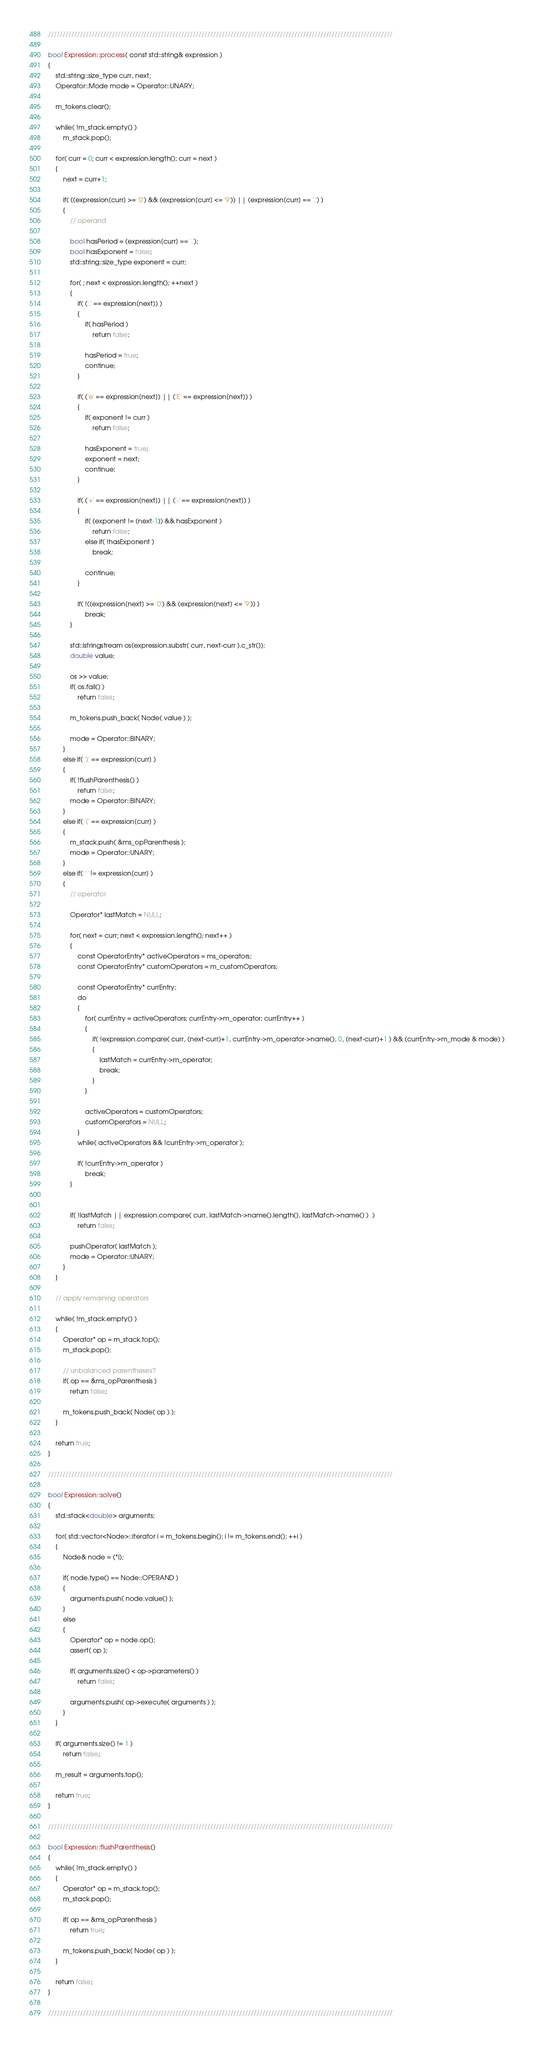Convert code to text. <code><loc_0><loc_0><loc_500><loc_500><_C++_>///////////////////////////////////////////////////////////////////////////////////////////////////////////////////////

bool Expression::process( const std::string& expression )
{
	std::string::size_type curr, next;
	Operator::Mode mode = Operator::UNARY;

	m_tokens.clear();

	while( !m_stack.empty() )
		m_stack.pop();

	for( curr = 0; curr < expression.length(); curr = next )
	{
		next = curr+1;

		if( ((expression[curr] >= '0') && (expression[curr] <= '9')) || (expression[curr] == '.') )
		{
			// operand

			bool hasPeriod = (expression[curr] == '.');
			bool hasExponent = false;
			std::string::size_type exponent = curr;

			for( ; next < expression.length(); ++next )
			{
				if( ('.' == expression[next]) )
				{
					if( hasPeriod )
						return false;

					hasPeriod = true;
					continue;
				}

				if( ('e' == expression[next]) || ('E' == expression[next]) )
				{
					if( exponent != curr )
						return false;

					hasExponent = true;
					exponent = next;
					continue;
				}

				if( ('+' == expression[next]) || ('-' == expression[next]) )
				{
					if( (exponent != (next-1)) && hasExponent )
						return false;
					else if( !hasExponent )
						break;

					continue;
				}
				
				if( !((expression[next] >= '0') && (expression[next] <= '9')) )
					break;
			}

			std::istringstream os(expression.substr( curr, next-curr ).c_str());
			double value;

			os >> value;
			if( os.fail() )
				return false;

			m_tokens.push_back( Node( value ) );

			mode = Operator::BINARY;
		}
		else if( ')' == expression[curr] )
		{
			if( !flushParenthesis() )
				return false;
			mode = Operator::BINARY;
		}
		else if( '(' == expression[curr] )
		{
			m_stack.push( &ms_opParenthesis );
			mode = Operator::UNARY;
		}
		else if( ' ' != expression[curr] )
		{
			// operator

			Operator* lastMatch = NULL;

			for( next = curr; next < expression.length(); next++ )
			{
				const OperatorEntry* activeOperators = ms_operators;
				const OperatorEntry* customOperators = m_customOperators;

				const OperatorEntry* currEntry;
				do
				{
					for( currEntry = activeOperators; currEntry->m_operator; currEntry++ )
					{
						if( !expression.compare( curr, (next-curr)+1, currEntry->m_operator->name(), 0, (next-curr)+1 ) && (currEntry->m_mode & mode) )
						{
							lastMatch = currEntry->m_operator;
							break;
						}
					}

					activeOperators = customOperators;
					customOperators = NULL;
				}
				while( activeOperators && !currEntry->m_operator );

				if( !currEntry->m_operator )
					break;
			}


			if( !lastMatch || expression.compare( curr, lastMatch->name().length(), lastMatch->name() )  )
				return false;

			pushOperator( lastMatch );
			mode = Operator::UNARY;
		}
	}

	// apply remaining operators

	while( !m_stack.empty() )
	{
		Operator* op = m_stack.top();
		m_stack.pop();

		// unbalanced parentheses?
		if( op == &ms_opParenthesis )
			return false;

		m_tokens.push_back( Node( op ) );
	}

	return true;
}

///////////////////////////////////////////////////////////////////////////////////////////////////////////////////////

bool Expression::solve()
{
	std::stack<double> arguments;

	for( std::vector<Node>::iterator i = m_tokens.begin(); i != m_tokens.end(); ++i )
	{
		Node& node = (*i);

		if( node.type() == Node::OPERAND )
		{
			arguments.push( node.value() );
		}
		else
		{
			Operator* op = node.op();
			assert( op );

			if( arguments.size() < op->parameters() )
				return false;

			arguments.push( op->execute( arguments ) );
		}
	}

	if( arguments.size() != 1 )
		return false;

	m_result = arguments.top();

	return true;
}

///////////////////////////////////////////////////////////////////////////////////////////////////////////////////////

bool Expression::flushParenthesis()
{
	while( !m_stack.empty() )
	{
		Operator* op = m_stack.top();
		m_stack.pop();

		if( op == &ms_opParenthesis )
			return true;

		m_tokens.push_back( Node( op ) );
	}

	return false;
}

///////////////////////////////////////////////////////////////////////////////////////////////////////////////////////
</code> 